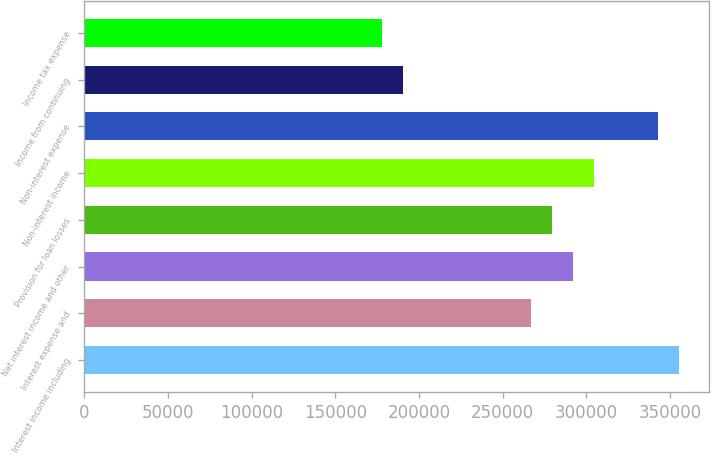Convert chart to OTSL. <chart><loc_0><loc_0><loc_500><loc_500><bar_chart><fcel>Interest income including<fcel>Interest expense and<fcel>Net interest income and other<fcel>Provision for loan losses<fcel>Non-interest income<fcel>Non-interest expense<fcel>Income from continuing<fcel>Income tax expense<nl><fcel>355522<fcel>266641<fcel>292036<fcel>279338<fcel>304733<fcel>342824<fcel>190458<fcel>177761<nl></chart> 